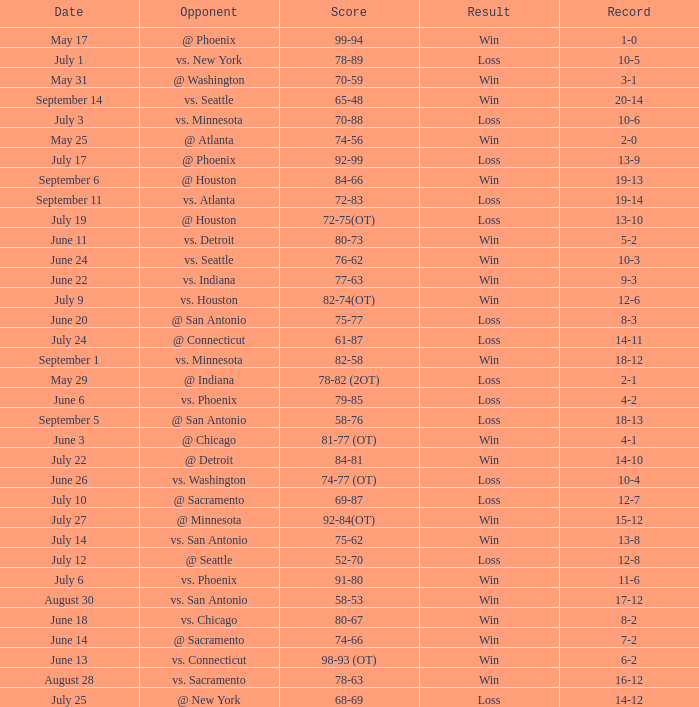What is the Record of the game on September 6? 19-13. 